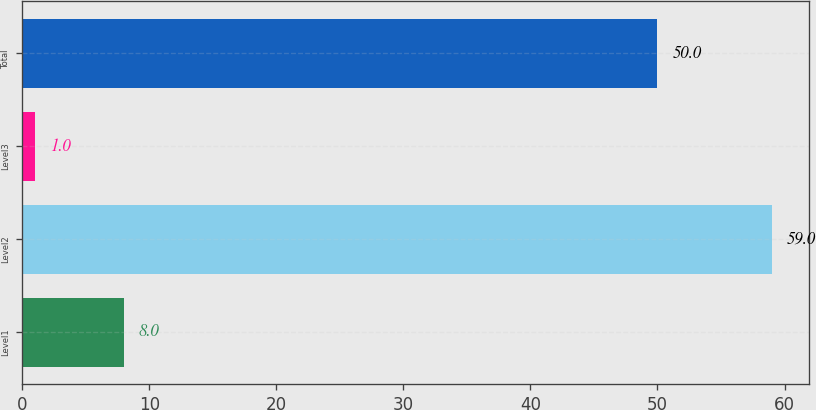<chart> <loc_0><loc_0><loc_500><loc_500><bar_chart><fcel>Level1<fcel>Level2<fcel>Level3<fcel>Total<nl><fcel>8<fcel>59<fcel>1<fcel>50<nl></chart> 